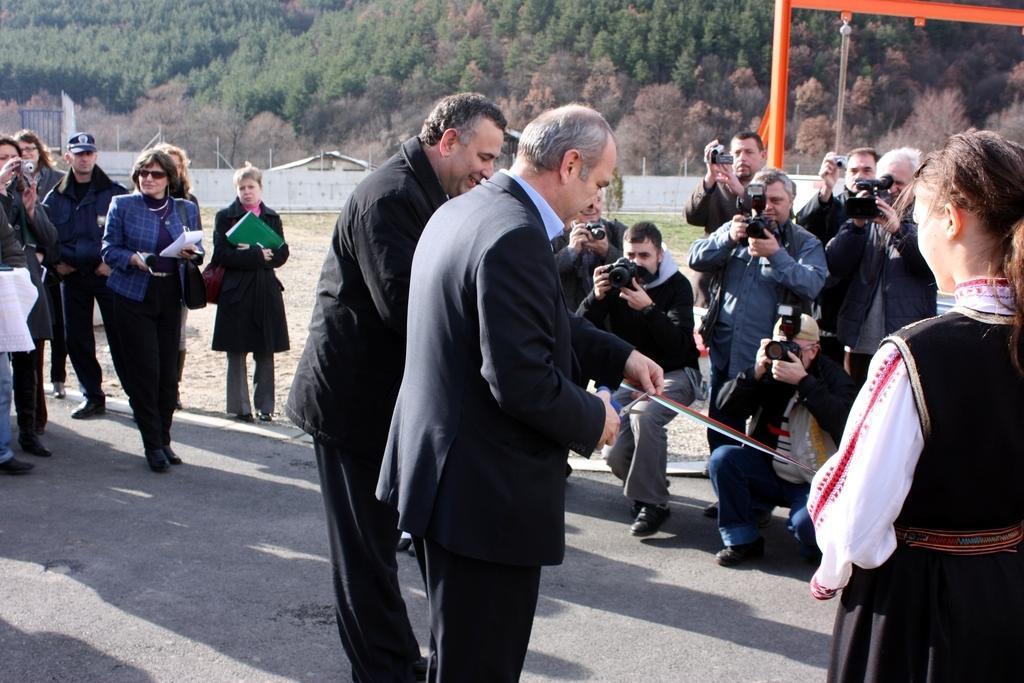Can you describe this image briefly? In this image we can see there are a few people standing on the ground and few people holding a camera and papers. And there is the person holding a scissor and cutting a ribbon. At the back we can see the wall, poles, shed and trees. 